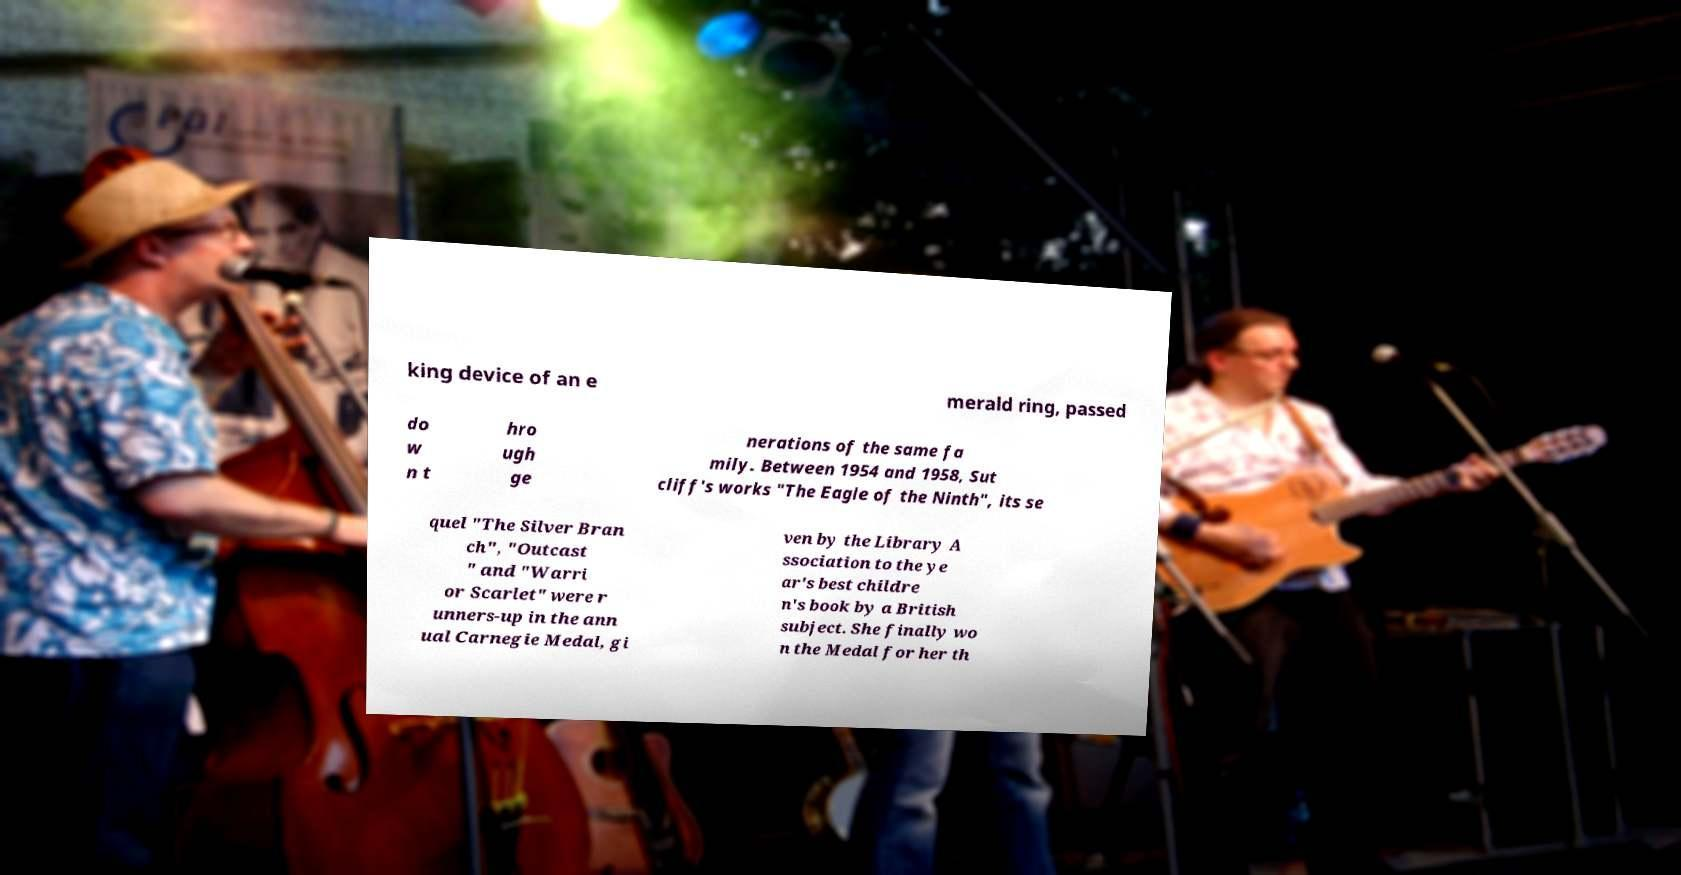Could you assist in decoding the text presented in this image and type it out clearly? king device of an e merald ring, passed do w n t hro ugh ge nerations of the same fa mily. Between 1954 and 1958, Sut cliff's works "The Eagle of the Ninth", its se quel "The Silver Bran ch", "Outcast " and "Warri or Scarlet" were r unners-up in the ann ual Carnegie Medal, gi ven by the Library A ssociation to the ye ar's best childre n's book by a British subject. She finally wo n the Medal for her th 